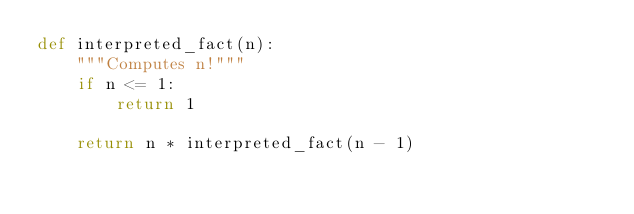<code> <loc_0><loc_0><loc_500><loc_500><_Python_>def interpreted_fact(n):
    """Computes n!"""
    if n <= 1:
        return 1

    return n * interpreted_fact(n - 1)
</code> 